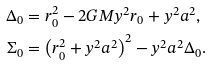<formula> <loc_0><loc_0><loc_500><loc_500>\Delta _ { 0 } & = r _ { 0 } ^ { 2 } - 2 G M y ^ { 2 } r _ { 0 } + y ^ { 2 } a ^ { 2 } , \\ \Sigma _ { 0 } & = \left ( r _ { 0 } ^ { 2 } + y ^ { 2 } a ^ { 2 } \right ) ^ { 2 } - y ^ { 2 } a ^ { 2 } \Delta _ { 0 } . \\</formula> 